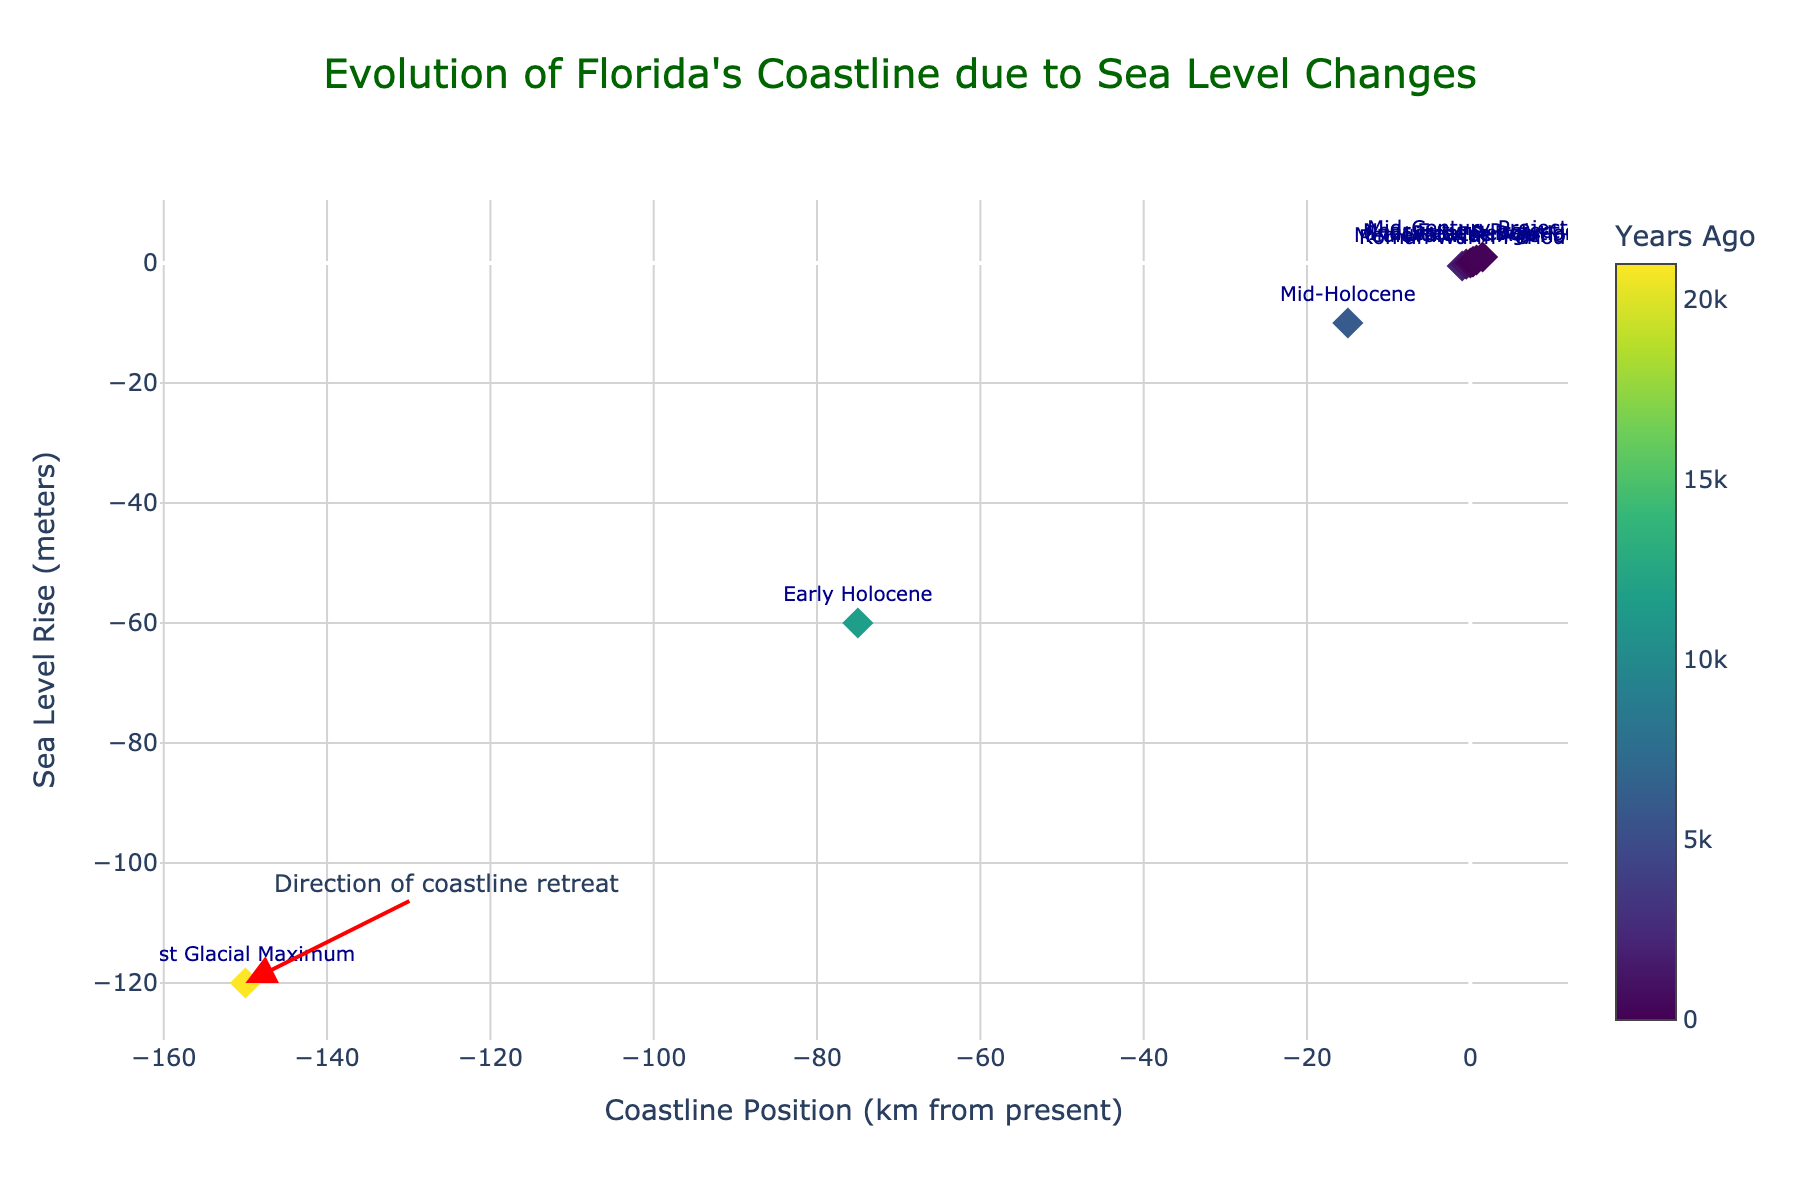What's the title of the figure? The title is found at the top center of the figure and reads: "Evolution of Florida's Coastline due to Sea Level Changes".
Answer: Evolution of Florida's Coastline due to Sea Level Changes What is the position of the coastline during the Last Glacial Maximum in km from the present? The plot shows the "Last Glacial Maximum" data point at approximately -150 km on the x-axis.
Answer: -150 km How many different time periods are represented in the plot? To find this, count the number of unique labels/text on the scatter points. There are 10 unique time periods represented.
Answer: 10 What is the sea level rise in meters at Present Day? The figure's y-axis position for the point labeled "Present Day" is approximately 0.23 meters.
Answer: 0.23 meters Which time period showed the highest rate of sea level rise projections, and what is that rise in meters? By examining the y-axis values, the "Mid-Century Projection" has the highest sea level rise of 1 meter.
Answer: Mid-Century Projection, 1 meter What is the color coding in the figure used to represent? The color scale (Viridis) is linked to "Years Ago", representing the period before the present day.
Answer: Years Ago Between which periods did the coastline retreat the most? The largest difference in coastline position can be observed between the "Last Glacial Maximum" at -150 km and the "Early Holocene" at -75 km, showing a 75 km retreat.
Answer: Between Last Glacial Maximum and Early Holocene How does the coastline position change from the Early Holocene to the Roman Warm Period? The coastline moves from approximately -75 km during the Early Holocene to about -1 km during the Roman Warm Period, a change of +74 km.
Answer: +74 km What is the difference in sea level rise between the Roman Warm Period and the Industrial Revolution? The Roman Warm Period had a sea level rise of -0.5 meters and the Industrial Revolution had a rise of 0.2 meters, making a difference of 0.7 meters (0.2 - (-0.5)).
Answer: 0.7 meters By how much is the coastline projected to move in the near future projection compared to the present day? The coastline moves from approximately 0.35 km at Present Day to 0.75 km in the Near Future Projection, a difference of 0.4 km.
Answer: 0.4 km 